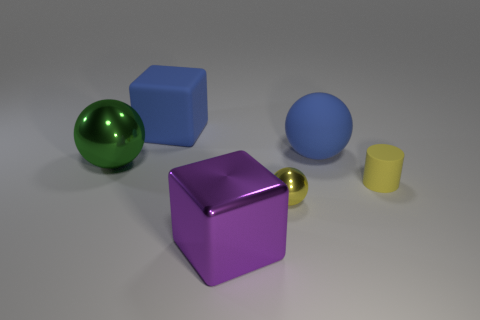Are there an equal number of blue rubber blocks to the left of the tiny cylinder and yellow matte things?
Provide a succinct answer. Yes. There is a large blue object that is to the right of the big block that is in front of the big green metallic object; how many matte spheres are on the left side of it?
Your response must be concise. 0. Is there anything else that has the same size as the green ball?
Keep it short and to the point. Yes. There is a purple shiny object; is it the same size as the blue matte object that is left of the tiny ball?
Provide a short and direct response. Yes. What number of yellow metallic objects are there?
Your response must be concise. 1. Do the rubber thing that is behind the matte sphere and the blue matte sphere that is behind the small matte object have the same size?
Provide a succinct answer. Yes. There is a tiny thing that is the same shape as the large green metallic object; what color is it?
Make the answer very short. Yellow. Do the purple object and the small yellow shiny thing have the same shape?
Provide a short and direct response. No. There is a blue matte object that is the same shape as the tiny metallic thing; what size is it?
Make the answer very short. Large. How many big objects are made of the same material as the cylinder?
Ensure brevity in your answer.  2. 